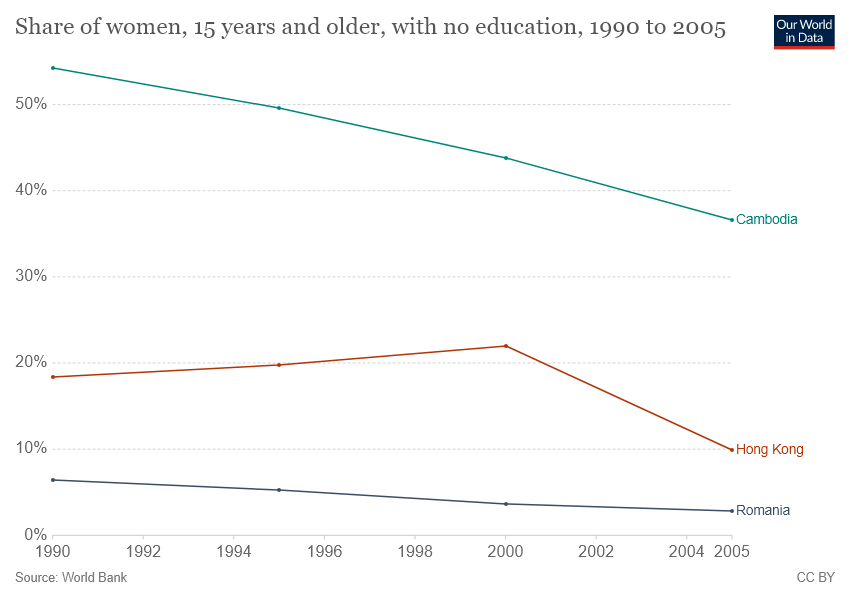Draw attention to some important aspects in this diagram. In the year 1990, the difference in percentage between Hong Kong and Cambodia was approximately 30%. 